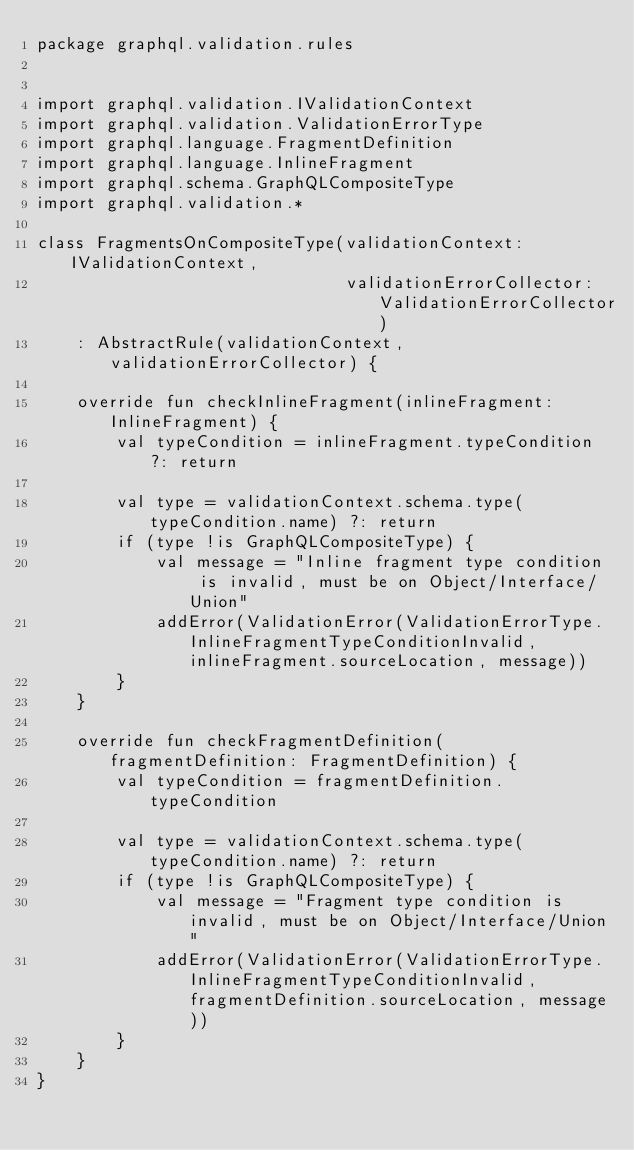<code> <loc_0><loc_0><loc_500><loc_500><_Kotlin_>package graphql.validation.rules


import graphql.validation.IValidationContext
import graphql.validation.ValidationErrorType
import graphql.language.FragmentDefinition
import graphql.language.InlineFragment
import graphql.schema.GraphQLCompositeType
import graphql.validation.*

class FragmentsOnCompositeType(validationContext: IValidationContext,
                               validationErrorCollector: ValidationErrorCollector)
    : AbstractRule(validationContext, validationErrorCollector) {

    override fun checkInlineFragment(inlineFragment: InlineFragment) {
        val typeCondition = inlineFragment.typeCondition ?: return

        val type = validationContext.schema.type(typeCondition.name) ?: return
        if (type !is GraphQLCompositeType) {
            val message = "Inline fragment type condition is invalid, must be on Object/Interface/Union"
            addError(ValidationError(ValidationErrorType.InlineFragmentTypeConditionInvalid, inlineFragment.sourceLocation, message))
        }
    }

    override fun checkFragmentDefinition(fragmentDefinition: FragmentDefinition) {
        val typeCondition = fragmentDefinition.typeCondition

        val type = validationContext.schema.type(typeCondition.name) ?: return
        if (type !is GraphQLCompositeType) {
            val message = "Fragment type condition is invalid, must be on Object/Interface/Union"
            addError(ValidationError(ValidationErrorType.InlineFragmentTypeConditionInvalid, fragmentDefinition.sourceLocation, message))
        }
    }
}
</code> 